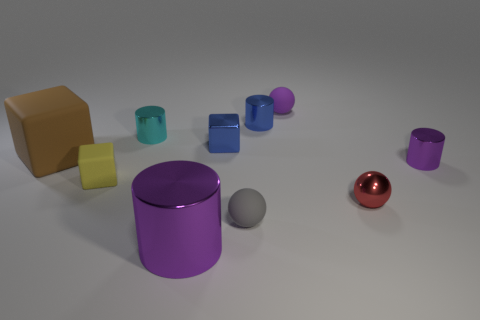What number of small gray things have the same material as the small yellow cube?
Offer a very short reply. 1. There is a large matte thing that is behind the small purple thing that is in front of the tiny blue metal object that is right of the blue cube; what is its color?
Give a very brief answer. Brown. Is the size of the brown rubber thing the same as the purple rubber object?
Your response must be concise. No. Is there any other thing that is the same shape as the small gray object?
Ensure brevity in your answer.  Yes. How many things are blocks that are left of the large cylinder or red shiny balls?
Your answer should be very brief. 3. Is the small red shiny thing the same shape as the big rubber thing?
Make the answer very short. No. How many other things are the same size as the cyan thing?
Provide a succinct answer. 7. What color is the large metallic cylinder?
Keep it short and to the point. Purple. How many large things are either cyan things or rubber cubes?
Make the answer very short. 1. Is the size of the purple rubber sphere that is behind the big purple thing the same as the purple cylinder on the left side of the small shiny ball?
Make the answer very short. No. 